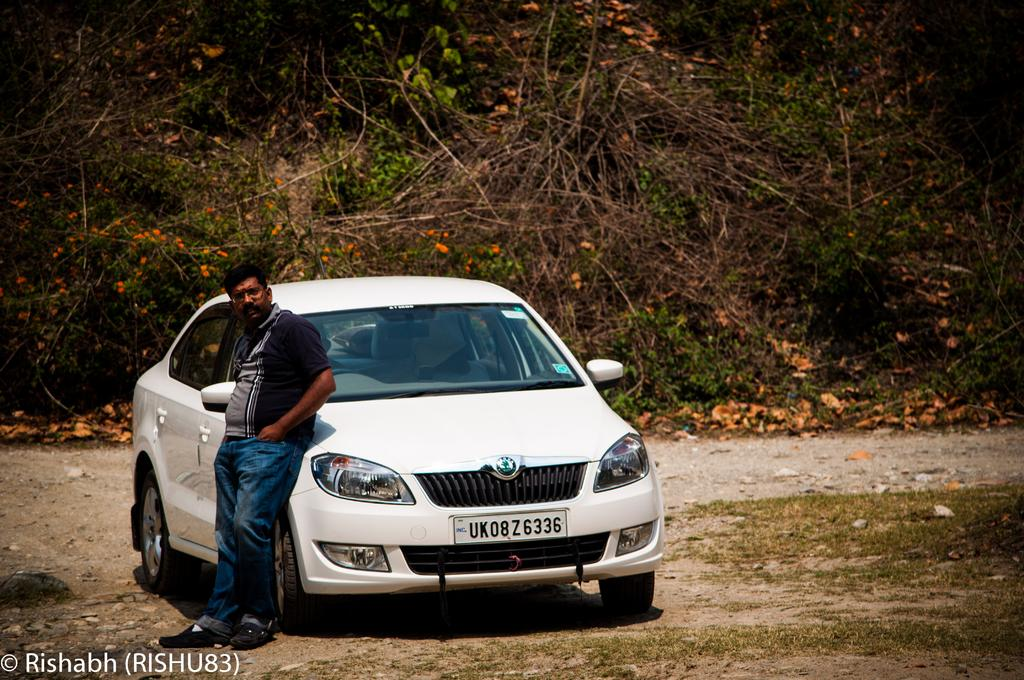What type of vegetation can be seen in the image? There are many trees and plants in the image. Are the plants in the image in bloom? Yes, the plants have flowers in the image. What type of man-made object is visible in the image? There is a car in the image. Can you describe the presence of a human in the image? There is a person in the image. What type of tin can be seen in the image? There is no tin present in the image. What color is the gold in the image? There is no gold present in the image. 